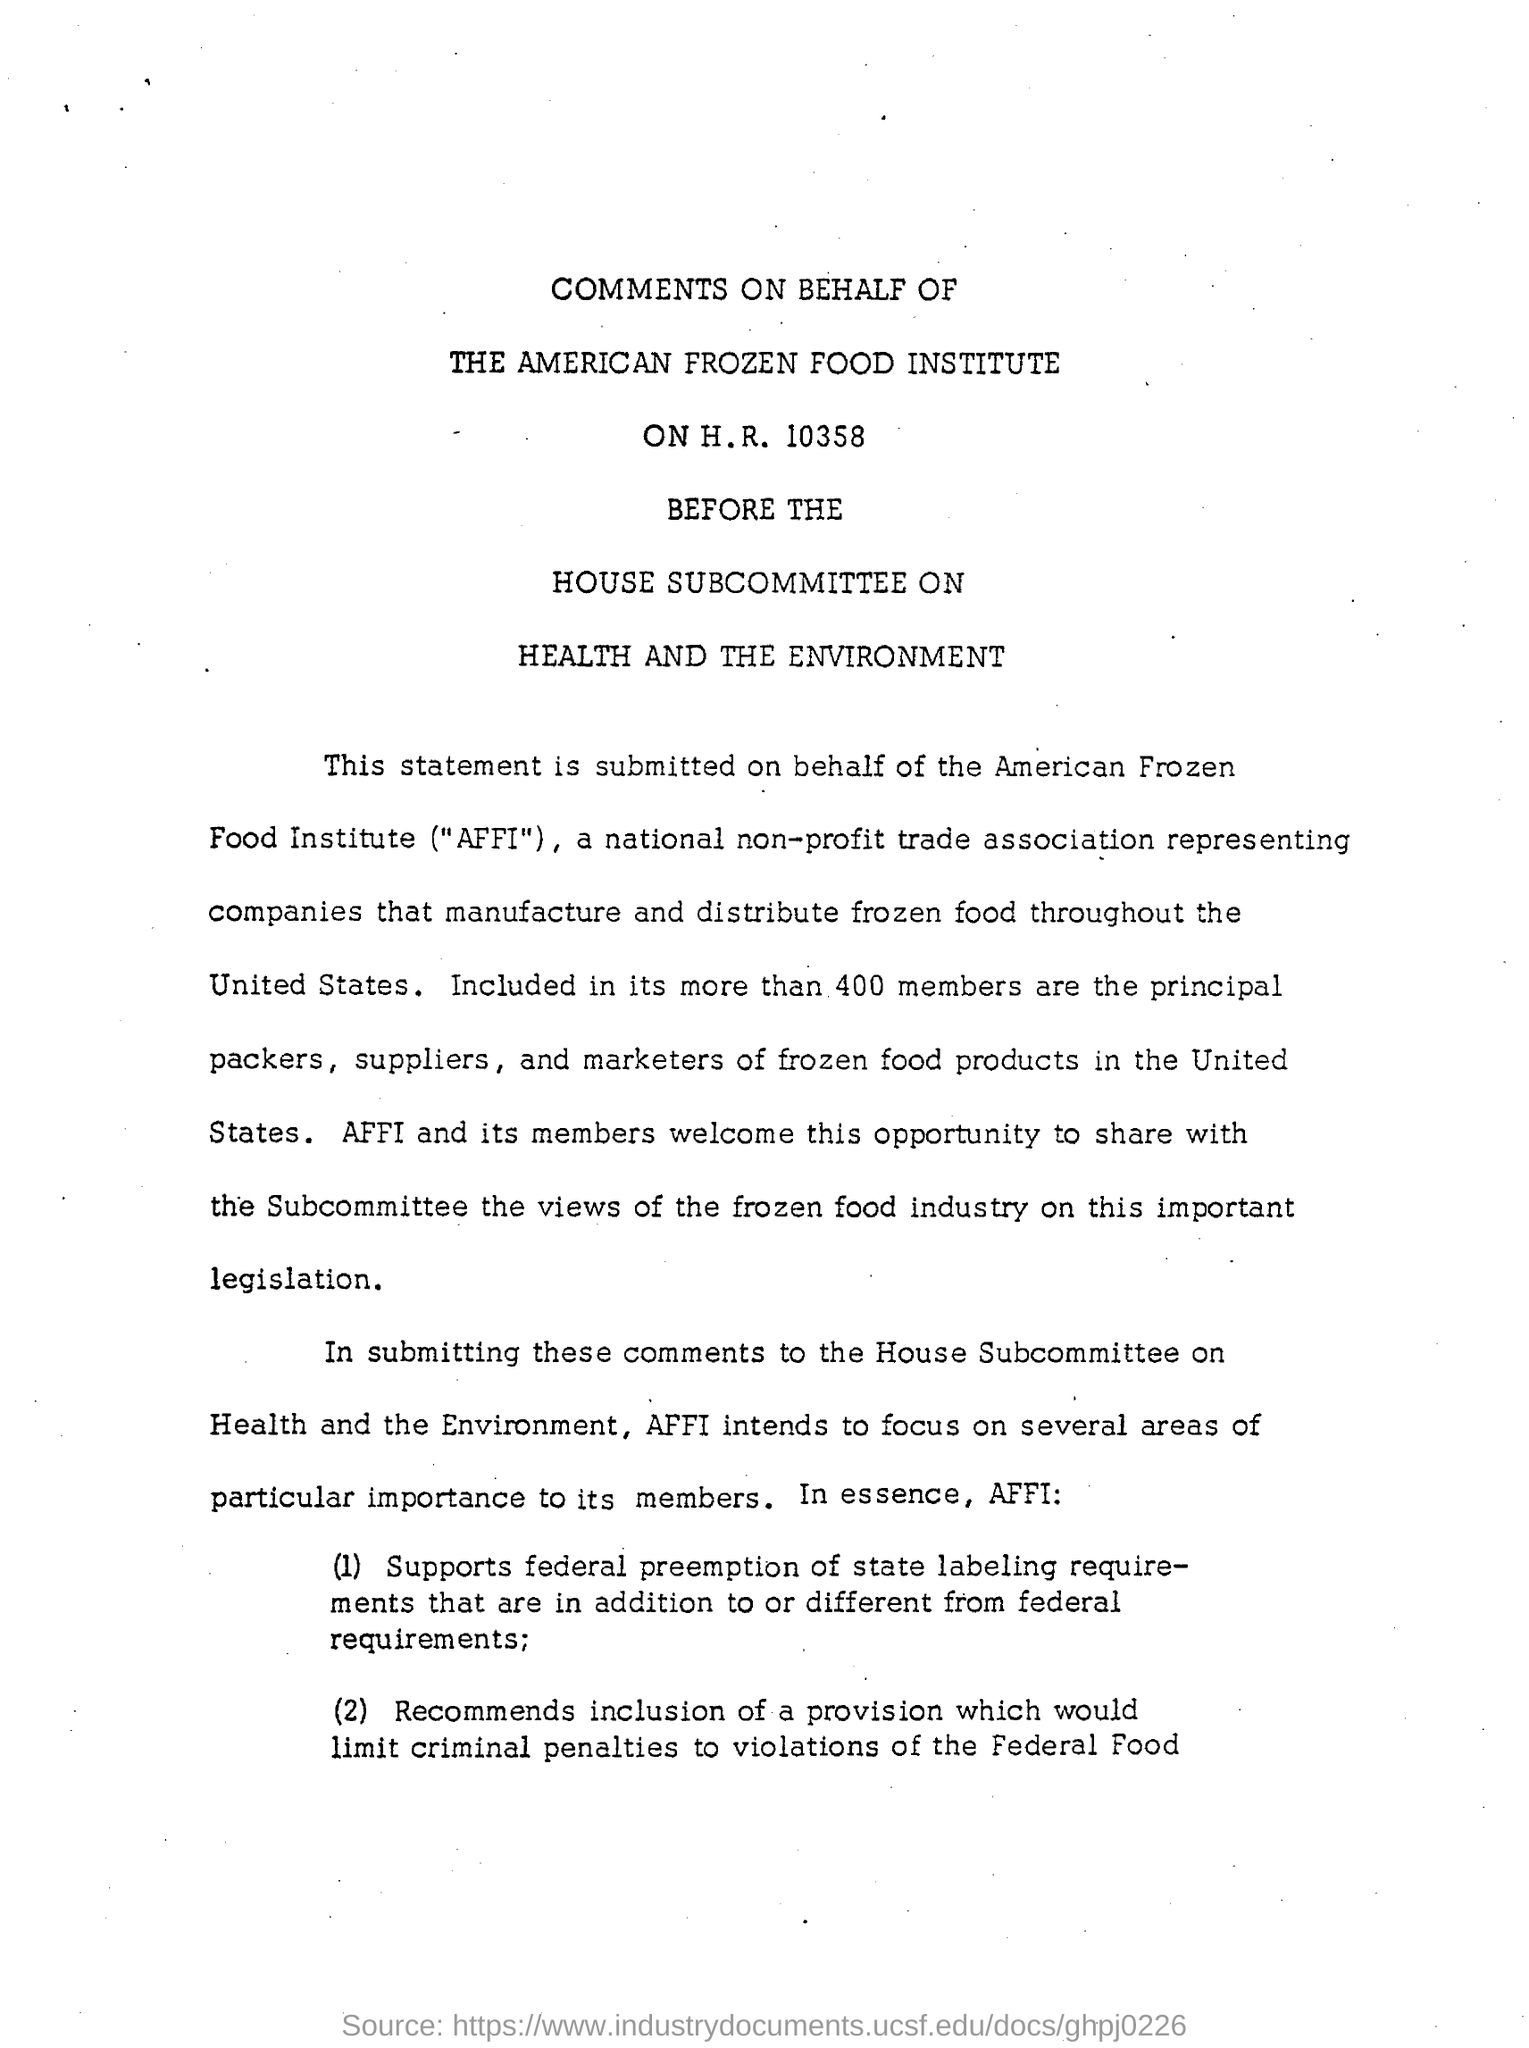Outline some significant characteristics in this image. The American Frozen Food Institute is the name of a food institute. There are more than 400 members in the frozen food institute. The American Frozen Food Institute (AFFI) is a recognized abbreviation that represents a prominent organization dedicated to the frozen food industry. 